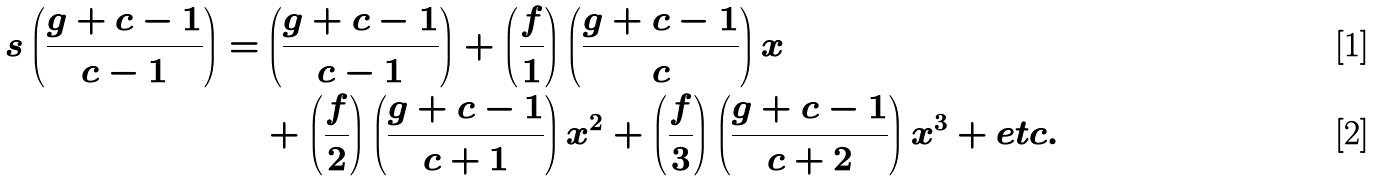Convert formula to latex. <formula><loc_0><loc_0><loc_500><loc_500>s \left ( \frac { g + c - 1 } { c - 1 } \right ) = & \left ( \frac { g + c - 1 } { c - 1 } \right ) + \left ( \frac { f } { 1 } \right ) \left ( \frac { g + c - 1 } { c } \right ) x \\ & + \left ( \frac { f } { 2 } \right ) \left ( \frac { g + c - 1 } { c + 1 } \right ) x ^ { 2 } + \left ( \frac { f } { 3 } \right ) \left ( \frac { g + c - 1 } { c + 2 } \right ) x ^ { 3 } + e t c .</formula> 